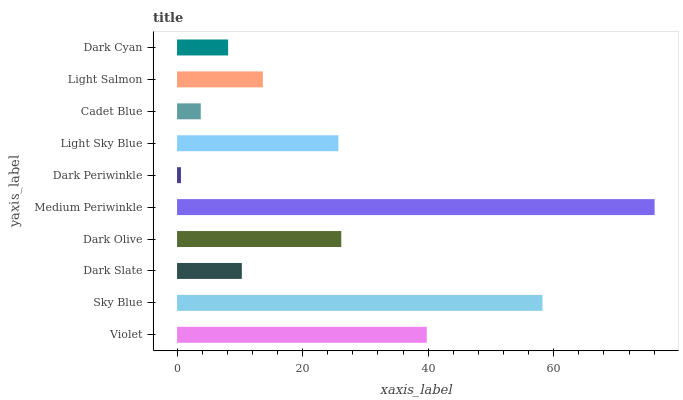Is Dark Periwinkle the minimum?
Answer yes or no. Yes. Is Medium Periwinkle the maximum?
Answer yes or no. Yes. Is Sky Blue the minimum?
Answer yes or no. No. Is Sky Blue the maximum?
Answer yes or no. No. Is Sky Blue greater than Violet?
Answer yes or no. Yes. Is Violet less than Sky Blue?
Answer yes or no. Yes. Is Violet greater than Sky Blue?
Answer yes or no. No. Is Sky Blue less than Violet?
Answer yes or no. No. Is Light Sky Blue the high median?
Answer yes or no. Yes. Is Light Salmon the low median?
Answer yes or no. Yes. Is Sky Blue the high median?
Answer yes or no. No. Is Violet the low median?
Answer yes or no. No. 